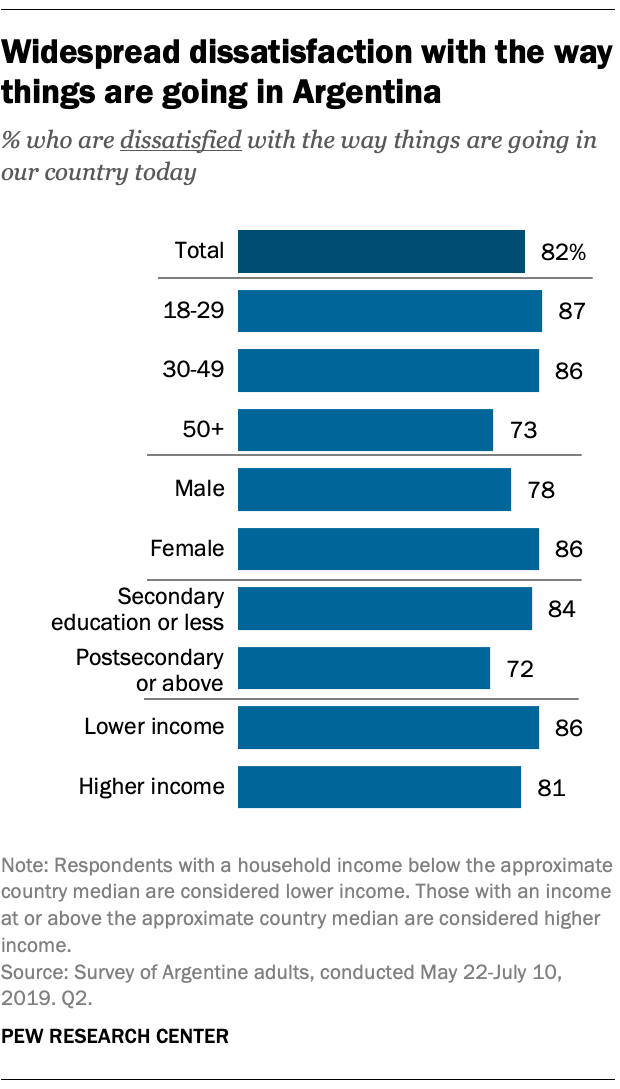Mention a couple of crucial points in this snapshot. The median of the first three blue bars from the top is not greater than the highest value of the blue bar. The value of the Male bar is 78. 